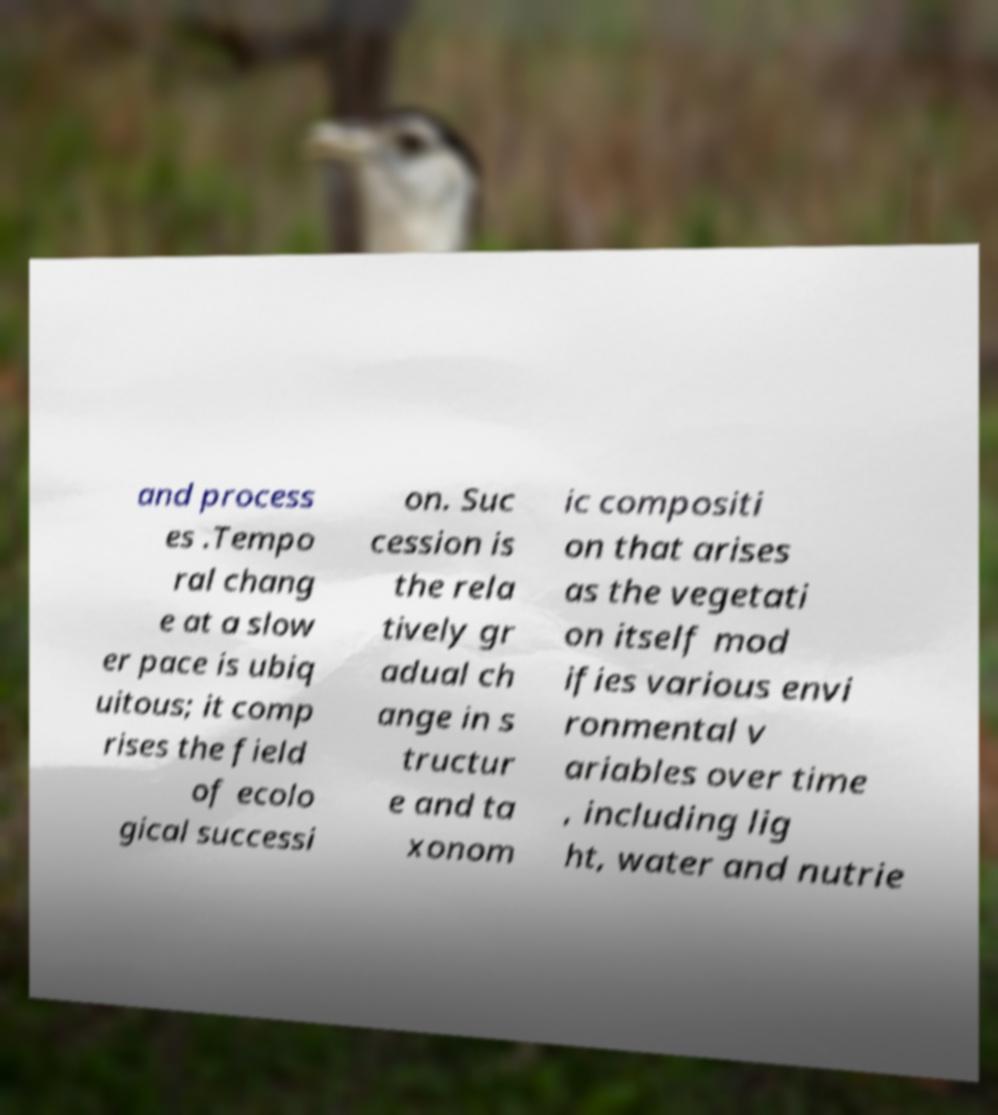Can you read and provide the text displayed in the image?This photo seems to have some interesting text. Can you extract and type it out for me? and process es .Tempo ral chang e at a slow er pace is ubiq uitous; it comp rises the field of ecolo gical successi on. Suc cession is the rela tively gr adual ch ange in s tructur e and ta xonom ic compositi on that arises as the vegetati on itself mod ifies various envi ronmental v ariables over time , including lig ht, water and nutrie 